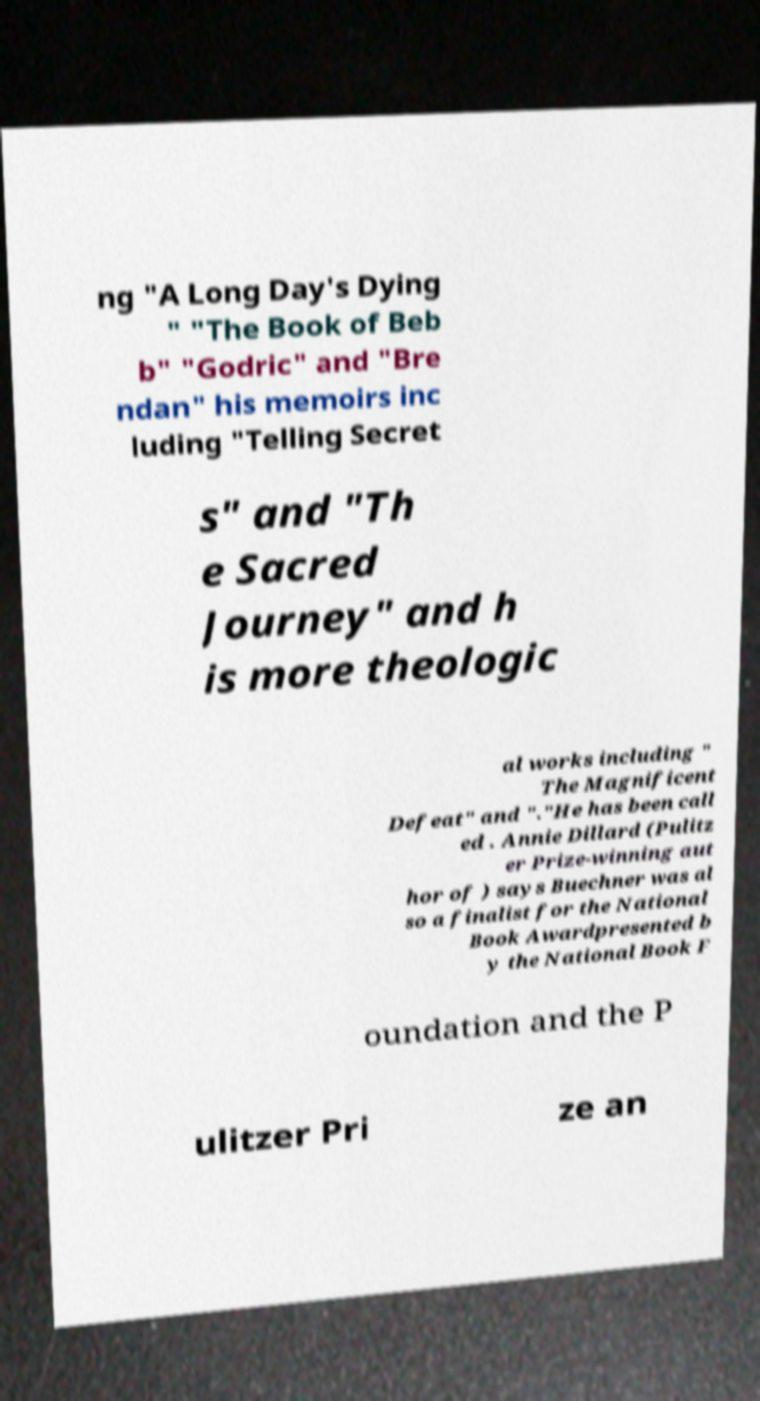What messages or text are displayed in this image? I need them in a readable, typed format. ng "A Long Day's Dying " "The Book of Beb b" "Godric" and "Bre ndan" his memoirs inc luding "Telling Secret s" and "Th e Sacred Journey" and h is more theologic al works including " The Magnificent Defeat" and "."He has been call ed . Annie Dillard (Pulitz er Prize-winning aut hor of ) says Buechner was al so a finalist for the National Book Awardpresented b y the National Book F oundation and the P ulitzer Pri ze an 